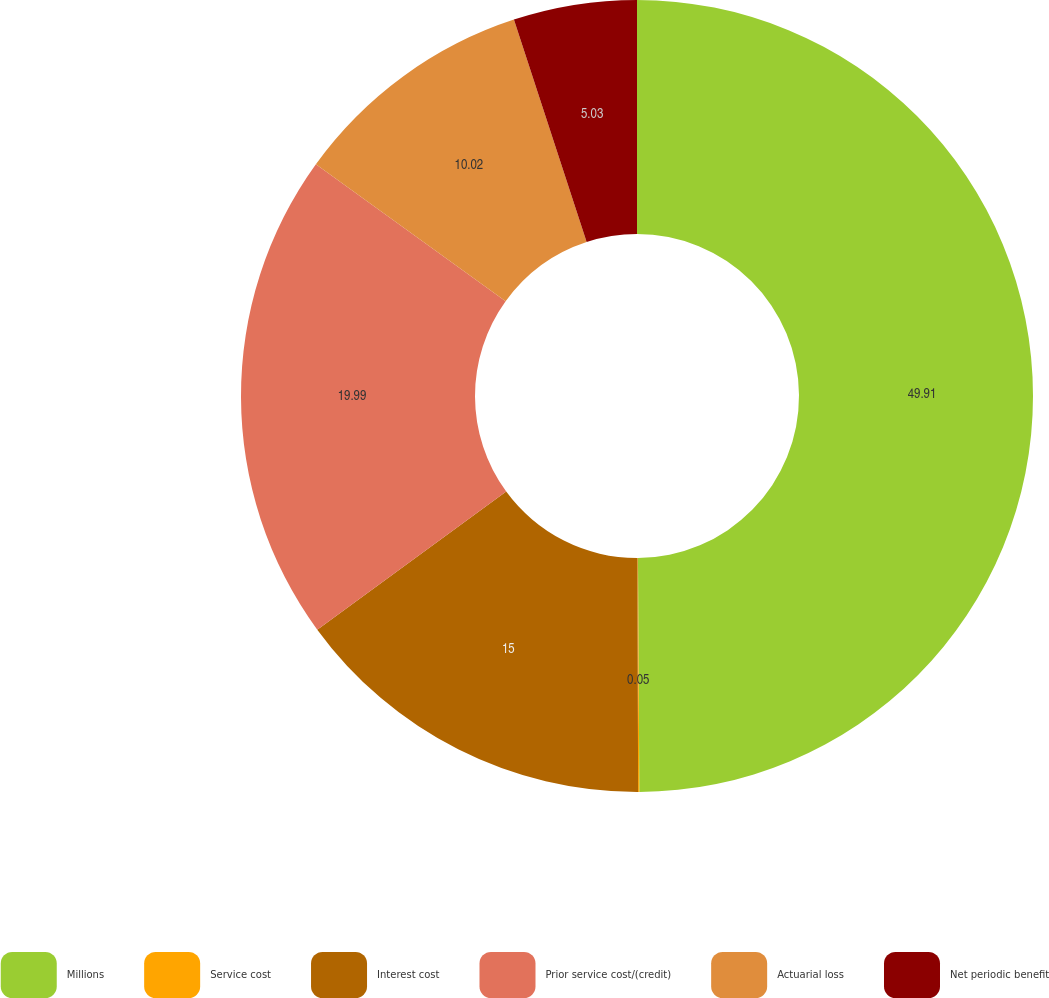Convert chart to OTSL. <chart><loc_0><loc_0><loc_500><loc_500><pie_chart><fcel>Millions<fcel>Service cost<fcel>Interest cost<fcel>Prior service cost/(credit)<fcel>Actuarial loss<fcel>Net periodic benefit<nl><fcel>49.9%<fcel>0.05%<fcel>15.0%<fcel>19.99%<fcel>10.02%<fcel>5.03%<nl></chart> 